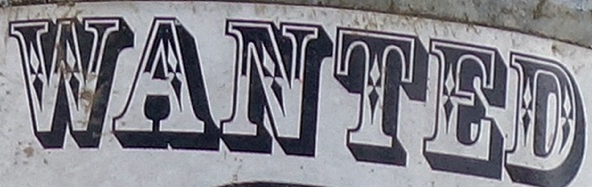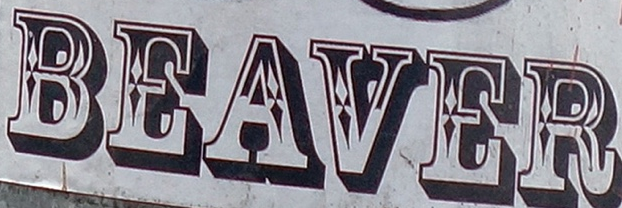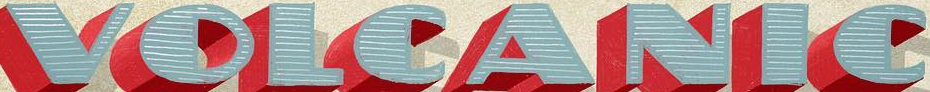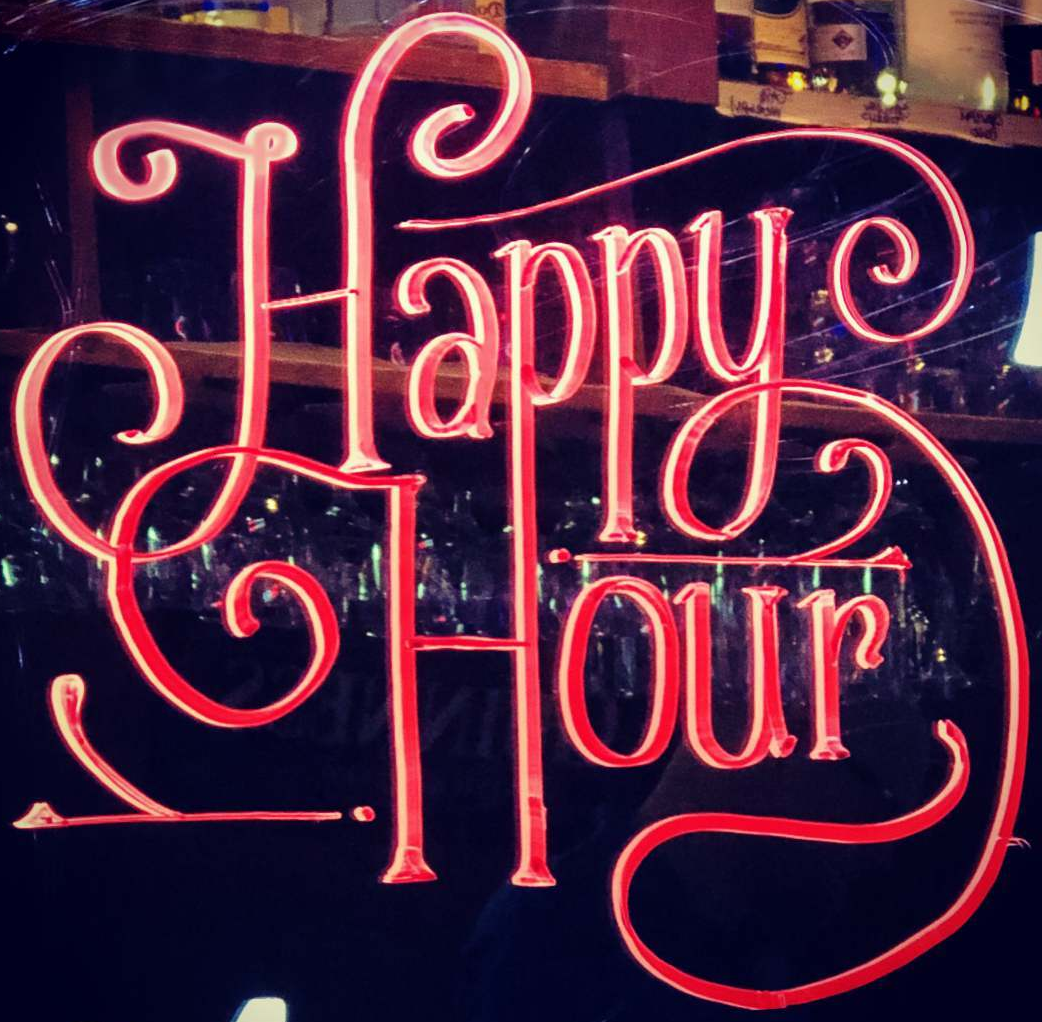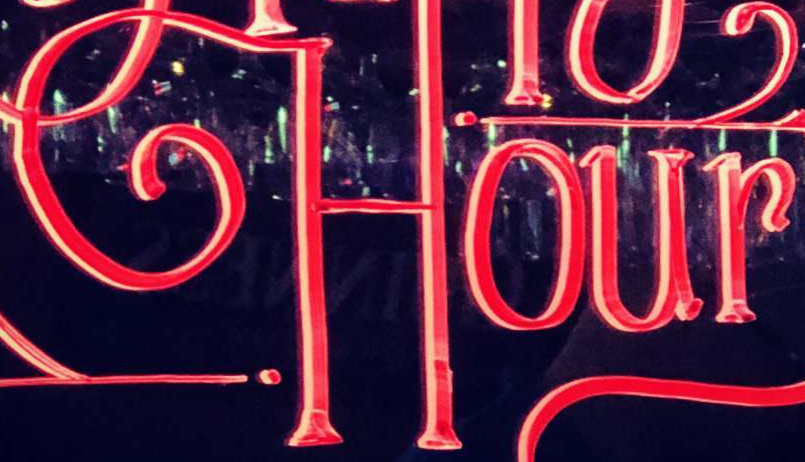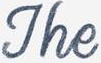What words can you see in these images in sequence, separated by a semicolon? WANTED; BEAVER; VOLCANIC; Happy; Hour; The 